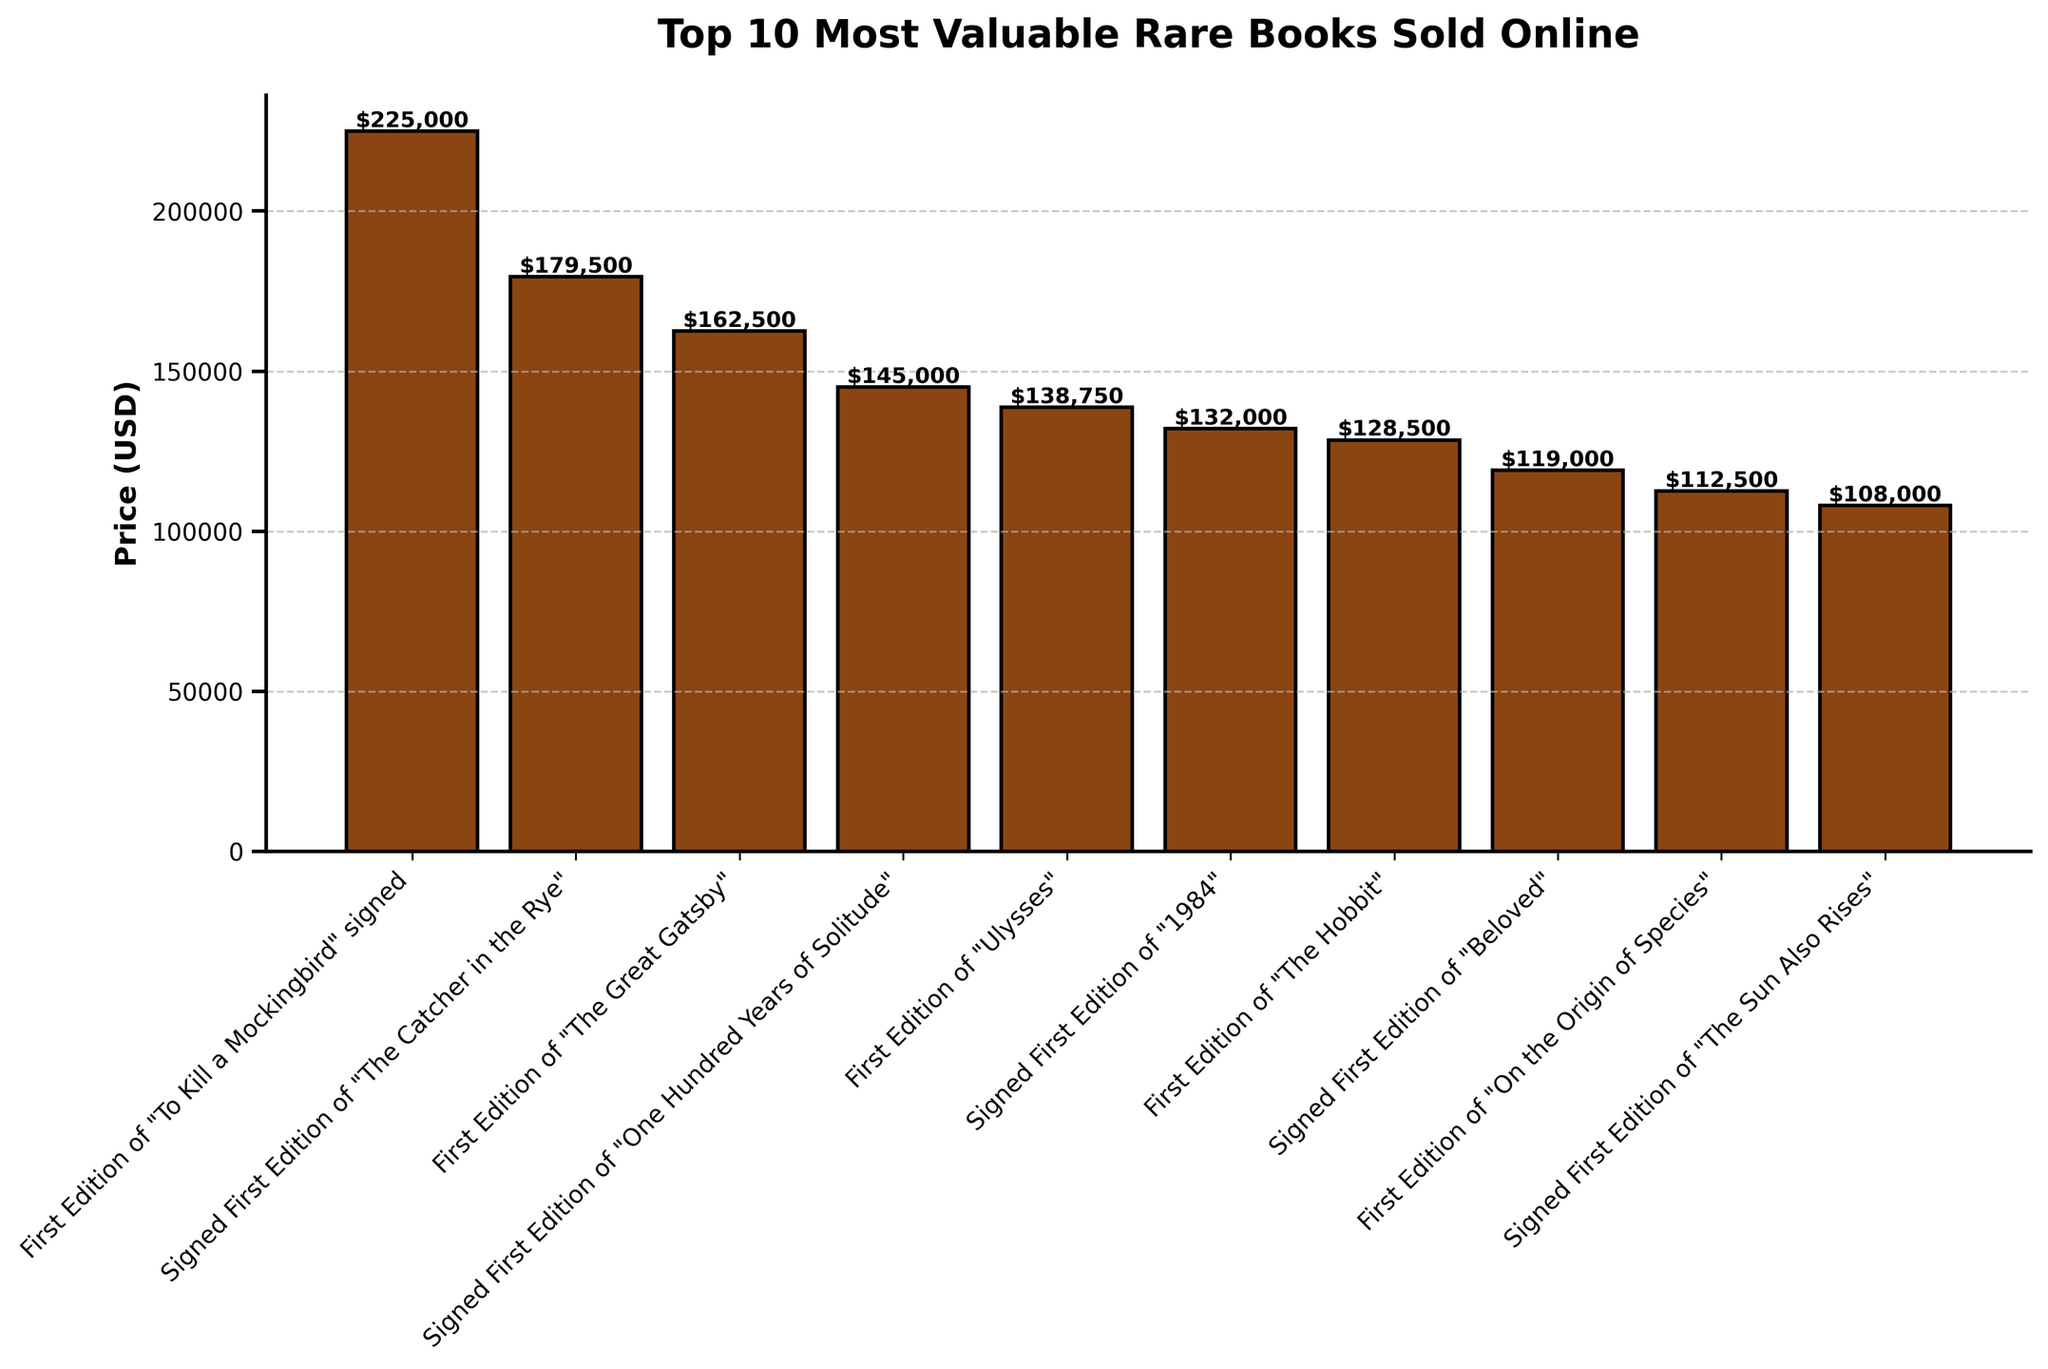Which book has the highest price? By visually identifying the tallest bar in the chart, we can see that the book "First Edition of 'To Kill a Mockingbird' signed by Harper Lee" has the highest price.
Answer: "First Edition of 'To Kill a Mockingbird' signed by Harper Lee" What is the difference in price between the most and the least valuable books? From the figure, the most valuable book is priced at $225,000 and the least valuable at $108,000. The difference is $225,000 - $108,000 = $117,000.
Answer: $117,000 How many books have prices over $140,000? By counting the bars that extend above the $140,000 mark, we see that there are 4 books in this range.
Answer: 4 Which author's signed first edition is worth $132,000? By examining the labels and corresponding prices, it is observed that the signed first edition of "1984" by George Orwell is priced at $132,000.
Answer: "1984" by George Orwell What is the cumulative price of the top 3 most valuable books? Adding together the top three prices: $225,000 (First Edition of "To Kill a Mockingbird"), $179,500 (Signed First Edition of "The Catcher in the Rye"), and $162,500 (First Edition of "The Great Gatsby"), the cumulative price is $225,000 + $179,500 + $162,500 = $567,000.
Answer: $567,000 What is the average price of the books listed? Adding all the prices, we get $225,000 + $179,500 + $162,500 + $145,000 + $138,750 + $132,000 + $128,500 + $119,000 + $112,500 + $108,000 = $1,450,750. Dividing by the number of books (10) gives us an average price of $1,450,750 / 10 = $145,075.
Answer: $145,075 Which book is the fourth most valuable? From the ordering of bars by height, the fourth tallest bar corresponds to the book "Signed First Edition of 'One Hundred Years of Solitude' by Gabriel García Márquez" priced at $145,000.
Answer: "Signed First Edition of 'One Hundred Years of Solitude' by Gabriel García Márquez" What is the price range of the books shown? The price range is found by subtracting the lowest price ($108,000) from the highest price ($225,000), which is $225,000 - $108,000 = $117,000.
Answer: $117,000 Which books have prices closest to $130,000? The books with prices closest to $130,000 are the "First Edition of 'Ulysses' by James Joyce" at $138,750 and the "First Edition of 'The Hobbit' by J.R.R. Tolkien" at $128,500.
Answer: "First Edition of 'Ulysses' by James Joyce" and "First Edition of 'The Hobbit' by J.R.R. Tolkien" How many books are priced between $100,000 and $150,000? Counting the bars that fall within the $100,000 to $150,000 price range, we find there are 7 books.
Answer: 7 